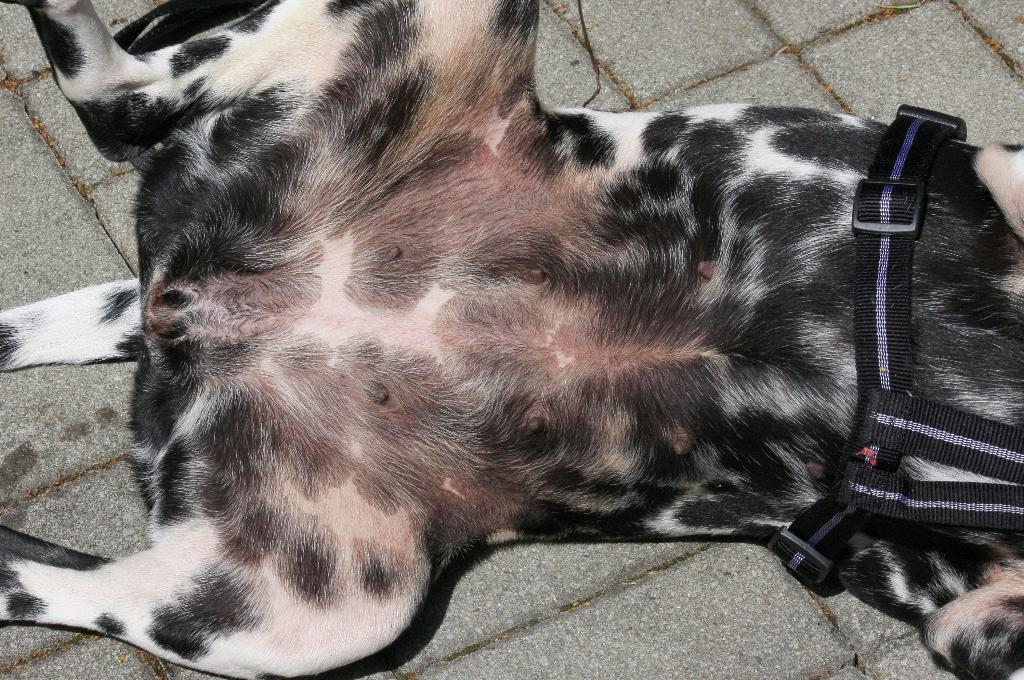What animal can be seen in the picture? There is a dog in the picture. What position is the dog in? The dog is lying on the floor. Where is the dog located in relation to the floor? The dog is in the center of the floor. What type of alarm is the dog using to wake up in the morning? There is no alarm present in the image, and the dog is not shown waking up. 